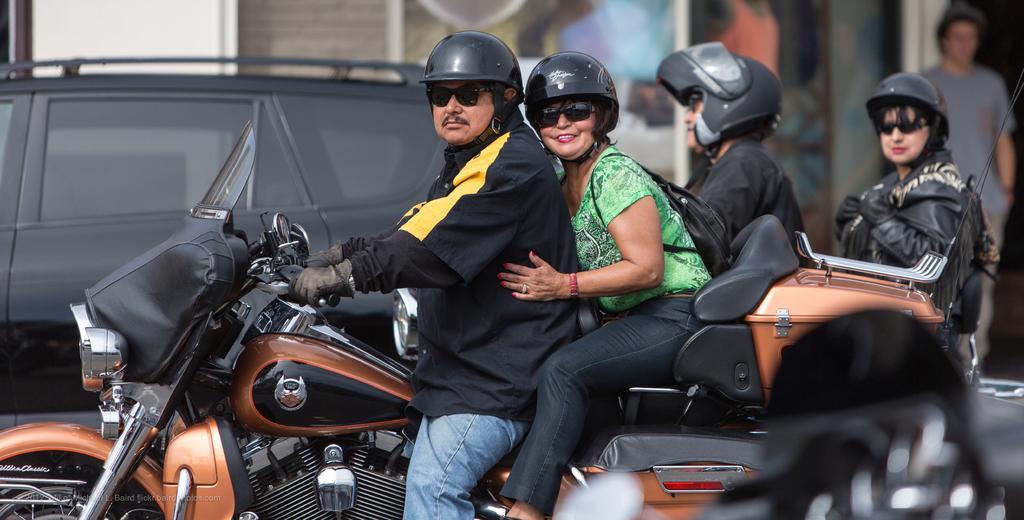Describe this image in one or two sentences. In this image i can see a man and a woman travelling on a bike at the background i can see a man and woman, a car and a wall. 